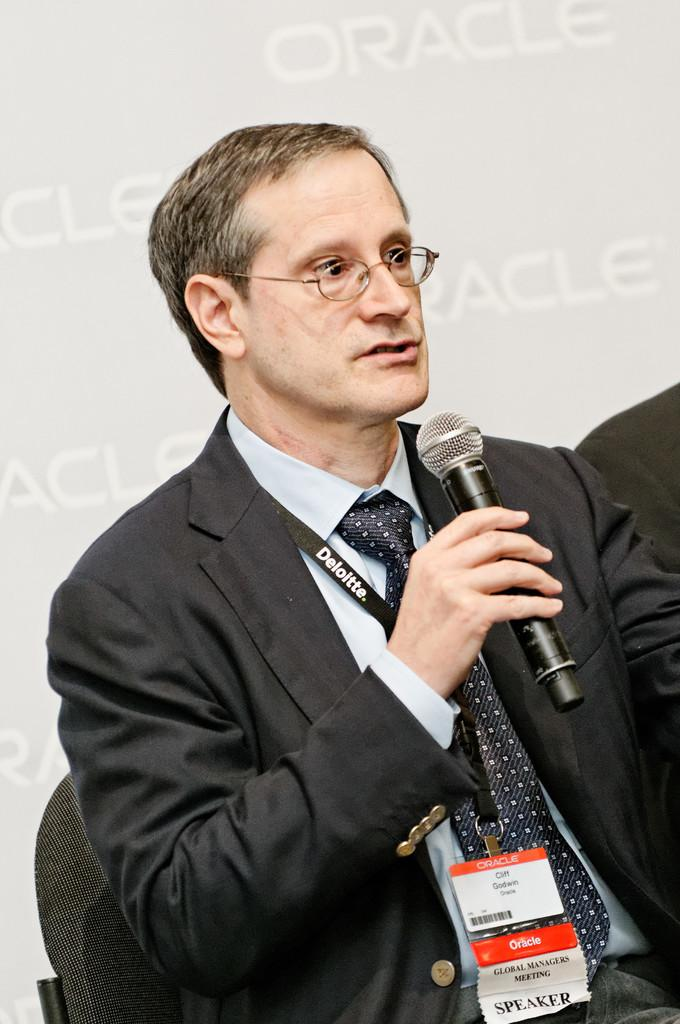What is the main subject of the image? There is a person in the image. What is the person doing in the image? The person is sitting on a chair and holding a mic in his hand. What type of glue is being used by the person in the image? There is no glue present in the image; the person is holding a mic. What appliance is the person using to gain approval in the image? There is no appliance or approval process depicted in the image; the person is simply sitting and holding a mic. 